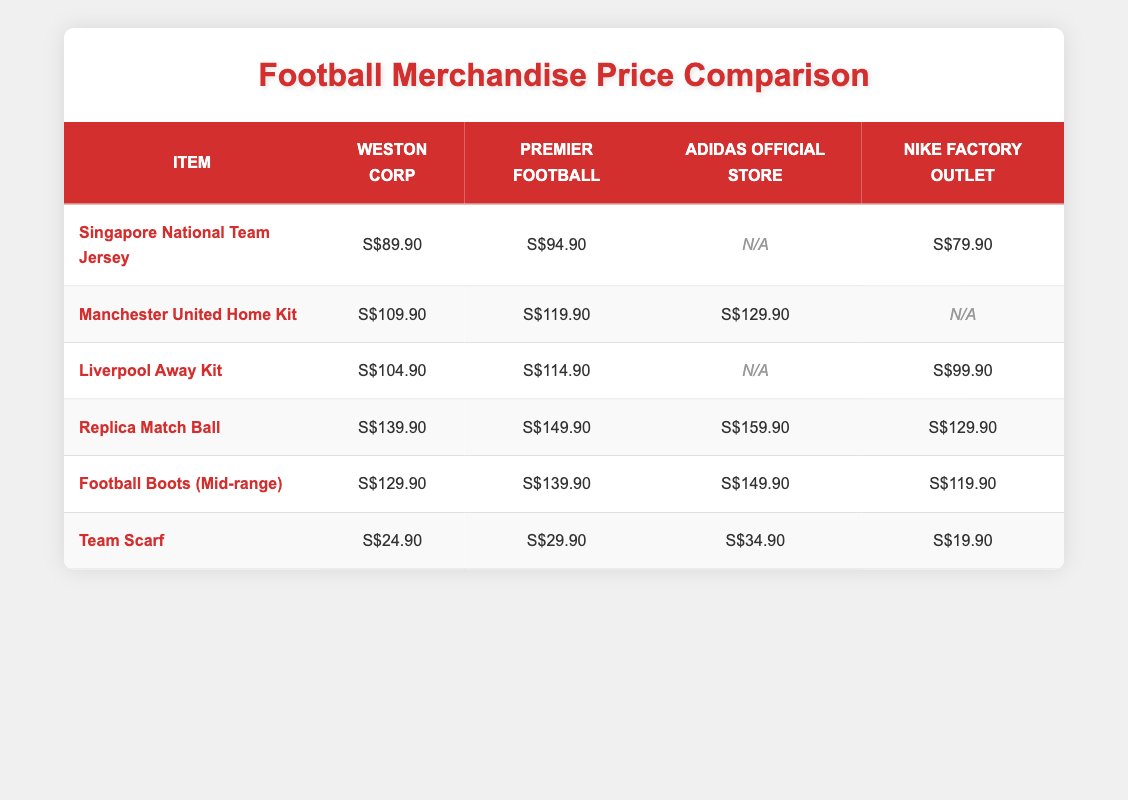What is the cheapest item available at the Nike Factory Outlet? The prices for items at the Nike Factory Outlet are listed. The cheapest price is S$19.90 for the Team Scarf.
Answer: S$19.90 Which retailer has the highest price for the Manchester United Home Kit? The prices for the Manchester United Home Kit are S$109.90 at Weston Corp, S$119.90 at Premier Football, S$129.90 at Adidas, and not available at Nike. The highest price is S$129.90 at Adidas Official Store.
Answer: S$129.90 Is the Liverpool Away Kit priced lower at Weston Corp or Premier Football? The prices for the Liverpool Away Kit are S$104.90 at Weston Corp and S$114.90 at Premier Football. Since 104.90 is less than 114.90, the lower price is at Weston Corp.
Answer: Weston Corp What is the total price if I buy both the Team Scarf and the Singapore National Team Jersey at Weston Corp? The Team Scarf costs S$24.90 and the Singapore National Team Jersey costs S$89.90. Adding these two amounts together gives us 24.90 + 89.90 = S$114.80.
Answer: S$114.80 Which retailer offers the best price for Football Boots (Mid-range)? The prices for Football Boots (Mid-range) are S$129.90 at Weston Corp, S$139.90 at Premier Football, S$149.90 at Adidas, and S$119.90 at Nike Factory Outlet. The best price is S$119.90 at Nike Factory Outlet.
Answer: S$119.90 Which kits are available at the Adidas Official Store? The only kits available at Adidas Official Store are the Manchester United Home Kit, priced at S$129.90, and the Replica Match Ball, priced at S$159.90. The Singapore National Team Jersey and Liverpool Away Kit are not available.
Answer: Manchester United Home Kit and Replica Match Ball What is the price difference between the cheapest and the most expensive items at Weston Corp? The cheapest item at Weston Corp is the Team Scarf at S$24.90, and the most expensive is the Replica Match Ball at S$139.90. To find the difference, subtract 24.90 from 139.90 giving 139.90 - 24.90 = S$115.00.
Answer: S$115.00 Is the price of the Replica Match Ball at Premier Football more than S$150? The price for the Replica Match Ball at Premier Football is S$149.90, which is not more than S$150. Therefore, the statement is false.
Answer: No Which retailer has the highest average price across all items available? To calculate the average price for each retailer, we take the sum of their available items and divide by the number of items. For example, Weston Corp's prices are S$89.90, S$109.90, S$104.90, S$139.90, S$129.90, and S$24.90, totaling S$598.90 divided by 6 gives an average of S$99.82. We need to calculate the same for the others and compare. Nike Factory Outlet appears to have the highest average.
Answer: Nike Factory Outlet 